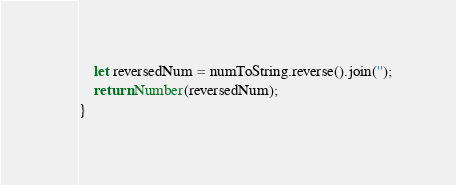<code> <loc_0><loc_0><loc_500><loc_500><_JavaScript_>    let reversedNum = numToString.reverse().join('');
    return Number(reversedNum);
}
</code> 